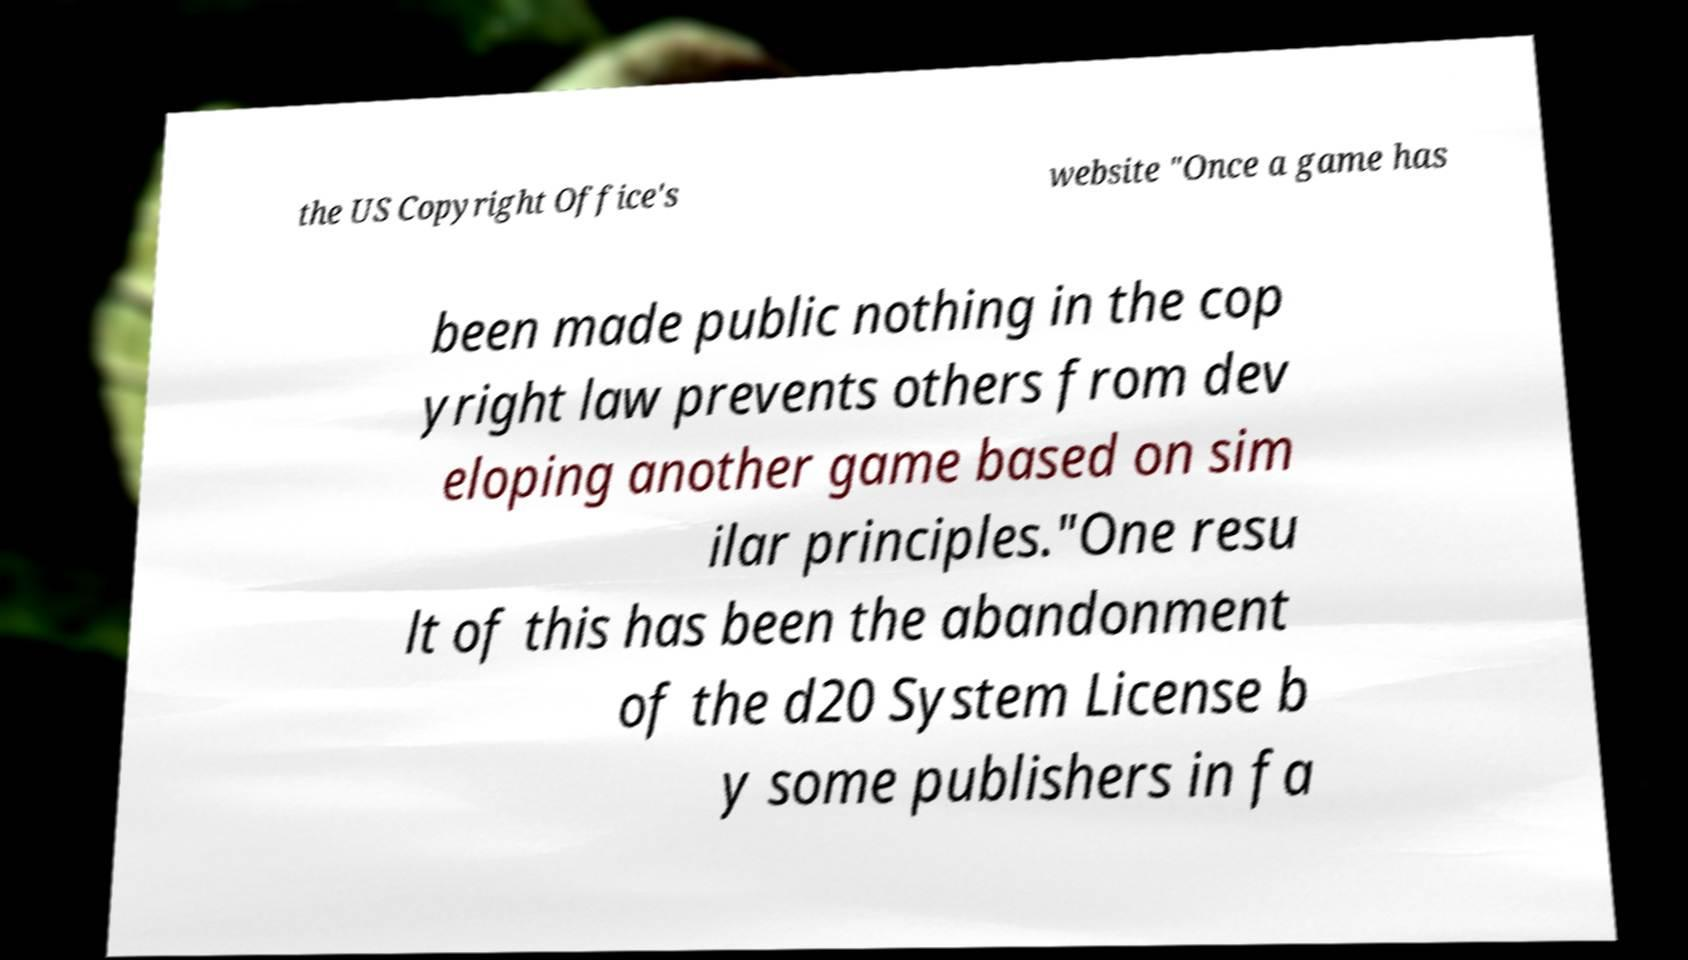Please identify and transcribe the text found in this image. the US Copyright Office's website "Once a game has been made public nothing in the cop yright law prevents others from dev eloping another game based on sim ilar principles."One resu lt of this has been the abandonment of the d20 System License b y some publishers in fa 